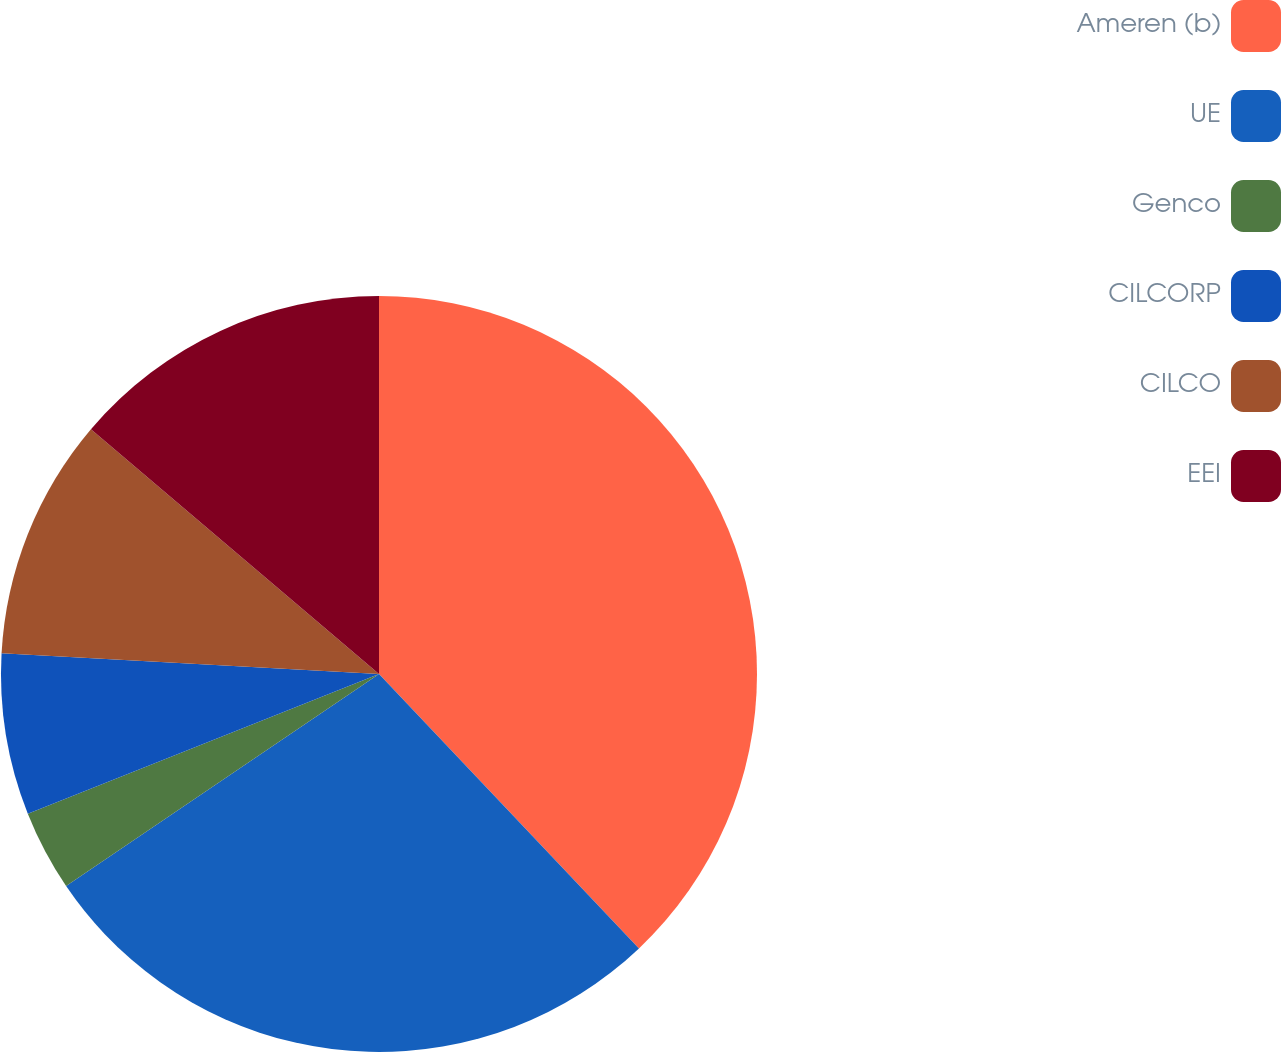Convert chart. <chart><loc_0><loc_0><loc_500><loc_500><pie_chart><fcel>Ameren (b)<fcel>UE<fcel>Genco<fcel>CILCORP<fcel>CILCO<fcel>EEI<nl><fcel>37.93%<fcel>27.59%<fcel>3.45%<fcel>6.9%<fcel>10.34%<fcel>13.79%<nl></chart> 